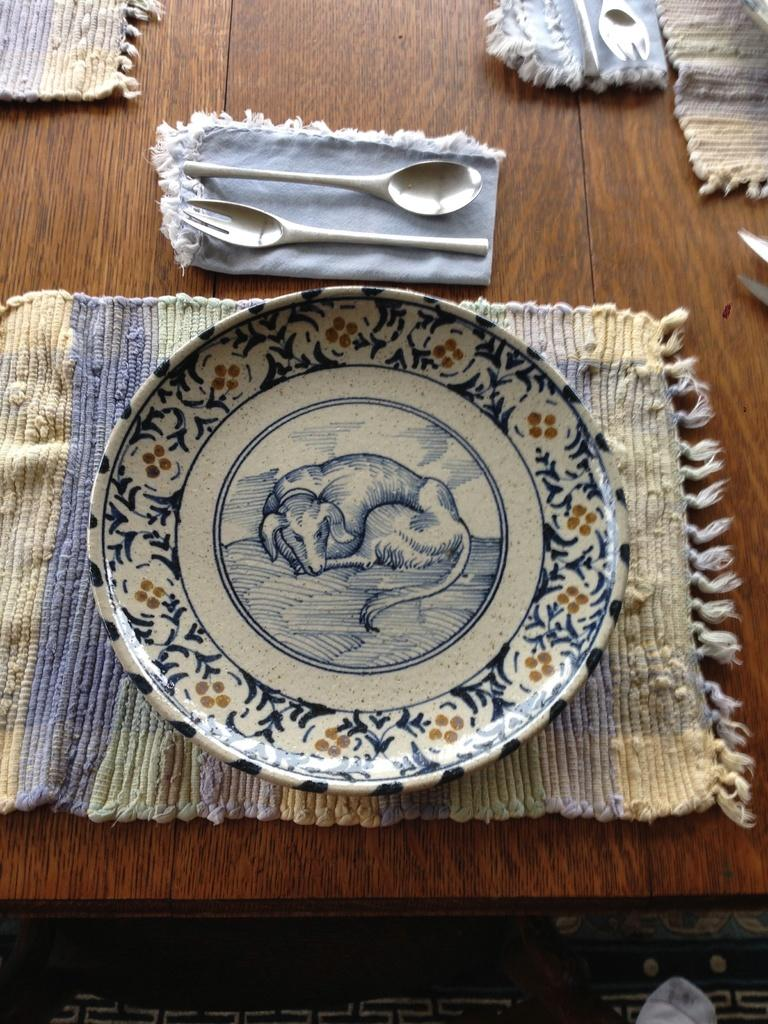What type of objects are on the table in the image? There are table mats, a well-designed plate, spoons, and forks on the table in the image. Can you describe the plate in the image? The plate in the image is well-designed. What type of utensils are visible in the image? Spoons and forks are present in the image. Where are all these objects located? All objects are on a table in the image. What type of vein can be seen running through the table mats in the image? There are no veins present in the table mats in the image. Can you describe the fangs on the forks in the image? There are no fangs on the forks in the image; they are standard utensils with prongs for gripping food. 